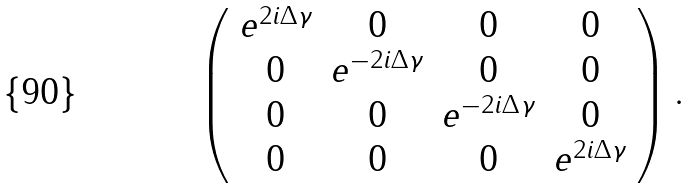Convert formula to latex. <formula><loc_0><loc_0><loc_500><loc_500>\left ( \begin{array} { c c c c } e ^ { 2 i \Delta \gamma } & 0 & 0 & 0 \\ 0 & e ^ { - 2 i \Delta \gamma } & 0 & 0 \\ 0 & 0 & e ^ { - 2 i \Delta \gamma } & 0 \\ 0 & 0 & 0 & e ^ { 2 i \Delta \gamma } \end{array} \right ) .</formula> 